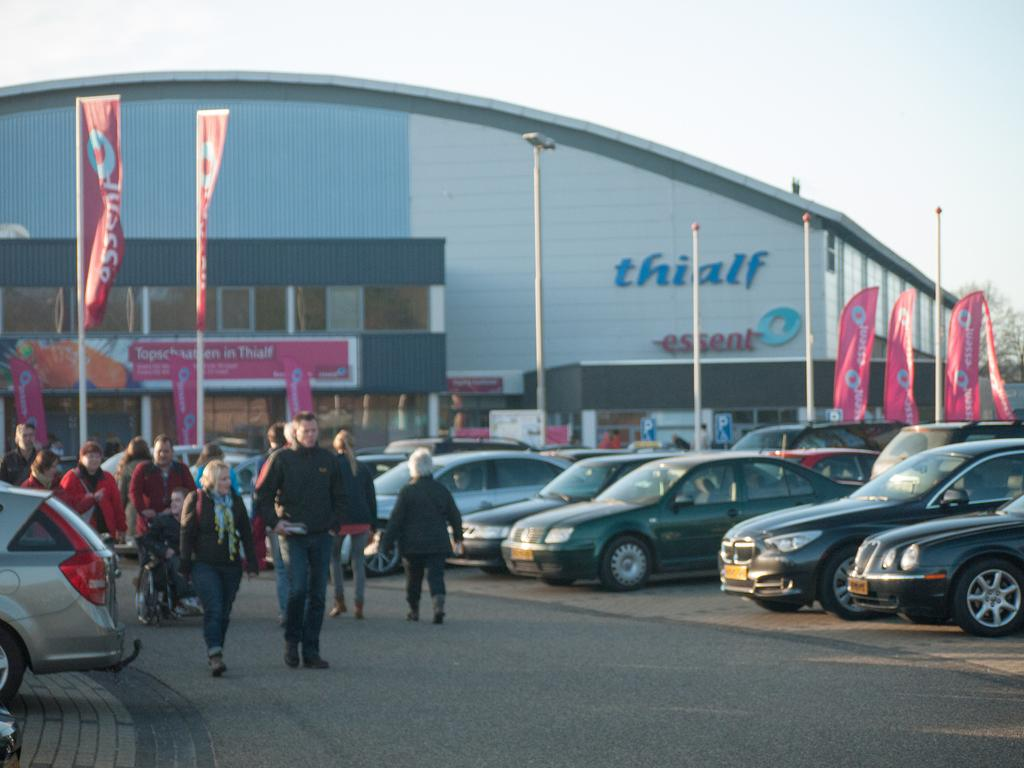What type of structure is visible in the image? There is a building in the image. What can be seen parked near the building? Cars are parked in the image. What are the people in the image doing? There are people walking on the road in the image. What type of vegetation is present in the image? There is a tree in the image. How would you describe the weather based on the image? The sky is cloudy in the image. What type of breakfast is being served in the image? There is no breakfast present in the image. Can you describe the hairstyles of the people walking in the image? The image does not provide enough detail to describe the hairstyles of the people walking. 